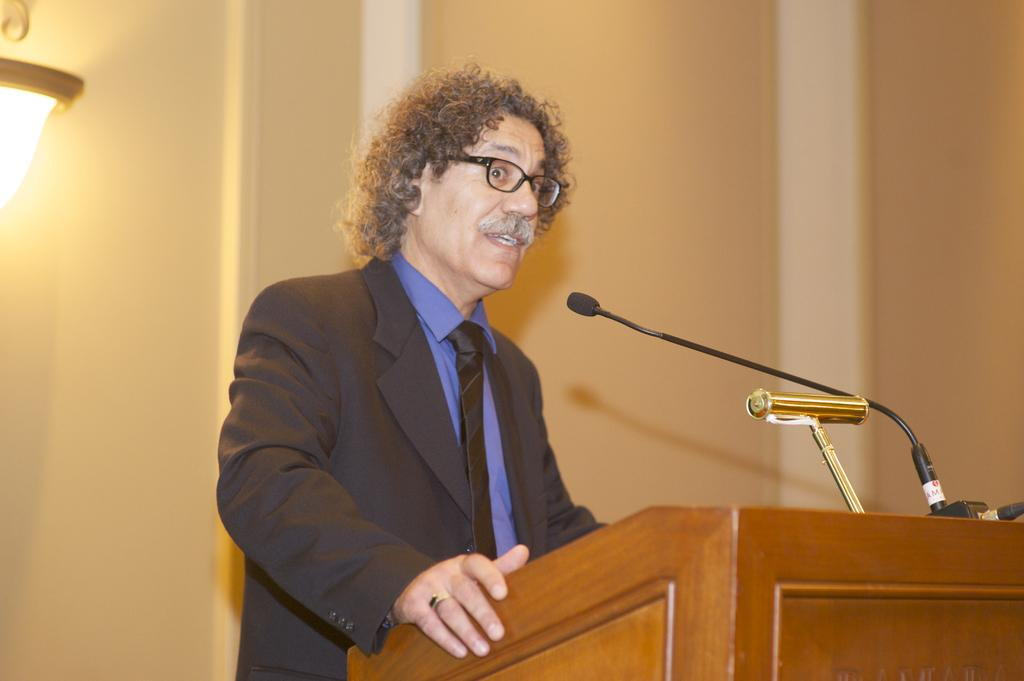Who is present in the image? There is a man in the image. What is the man doing in the image? The man is standing in front of a table and speaking. What is behind the man in the image? There is a wall behind the man. Can you describe the lighting in the image? There is a light attached to the wall on the left side. What shape is the kitten making on the table in the image? There is no kitten present in the image, so it cannot be making any shapes on the table. 